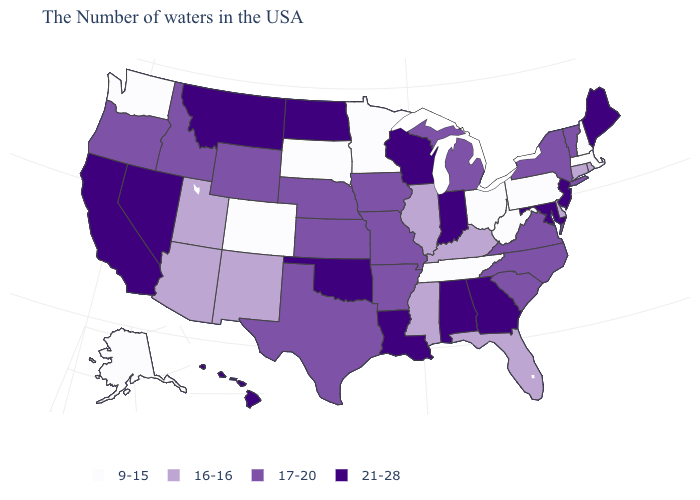Does Maine have the same value as Indiana?
Keep it brief. Yes. Name the states that have a value in the range 21-28?
Short answer required. Maine, New Jersey, Maryland, Georgia, Indiana, Alabama, Wisconsin, Louisiana, Oklahoma, North Dakota, Montana, Nevada, California, Hawaii. Among the states that border Massachusetts , does New Hampshire have the lowest value?
Write a very short answer. Yes. What is the lowest value in states that border Connecticut?
Concise answer only. 9-15. Which states have the lowest value in the USA?
Concise answer only. Massachusetts, New Hampshire, Pennsylvania, West Virginia, Ohio, Tennessee, Minnesota, South Dakota, Colorado, Washington, Alaska. Among the states that border Virginia , does Tennessee have the lowest value?
Short answer required. Yes. Name the states that have a value in the range 21-28?
Short answer required. Maine, New Jersey, Maryland, Georgia, Indiana, Alabama, Wisconsin, Louisiana, Oklahoma, North Dakota, Montana, Nevada, California, Hawaii. Does Louisiana have the same value as Kentucky?
Write a very short answer. No. Name the states that have a value in the range 17-20?
Concise answer only. Vermont, New York, Virginia, North Carolina, South Carolina, Michigan, Missouri, Arkansas, Iowa, Kansas, Nebraska, Texas, Wyoming, Idaho, Oregon. Does Texas have a higher value than South Dakota?
Short answer required. Yes. Name the states that have a value in the range 9-15?
Be succinct. Massachusetts, New Hampshire, Pennsylvania, West Virginia, Ohio, Tennessee, Minnesota, South Dakota, Colorado, Washington, Alaska. What is the value of New Hampshire?
Be succinct. 9-15. Does Georgia have a higher value than West Virginia?
Write a very short answer. Yes. Does the map have missing data?
Answer briefly. No. What is the highest value in the USA?
Concise answer only. 21-28. 